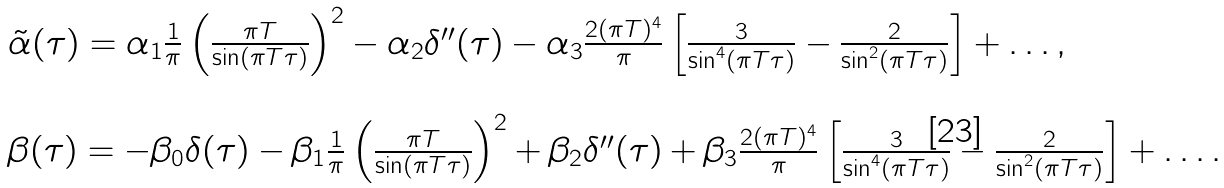<formula> <loc_0><loc_0><loc_500><loc_500>\begin{array} { l } \tilde { \alpha } ( \tau ) = \alpha _ { 1 } \frac { 1 } { \pi } \left ( \frac { \pi T } { \sin ( \pi T \tau ) } \right ) ^ { 2 } - \alpha _ { 2 } \delta ^ { \prime \prime } ( \tau ) - \alpha _ { 3 } \frac { 2 ( \pi T ) ^ { 4 } } { \pi } \left [ \frac { 3 } { \sin ^ { 4 } ( \pi T \tau ) } - \frac { 2 } { \sin ^ { 2 } ( \pi T \tau ) } \right ] + \dots , \\ \\ \beta ( \tau ) = - \beta _ { 0 } \delta ( \tau ) - \beta _ { 1 } \frac { 1 } { \pi } \left ( \frac { \pi T } { \sin ( \pi T \tau ) } \right ) ^ { 2 } + \beta _ { 2 } \delta ^ { \prime \prime } ( \tau ) + \beta _ { 3 } \frac { 2 ( \pi T ) ^ { 4 } } { \pi } \left [ \frac { 3 } { \sin ^ { 4 } ( \pi T \tau ) } - \frac { 2 } { \sin ^ { 2 } ( \pi T \tau ) } \right ] + \dots . \end{array}</formula> 